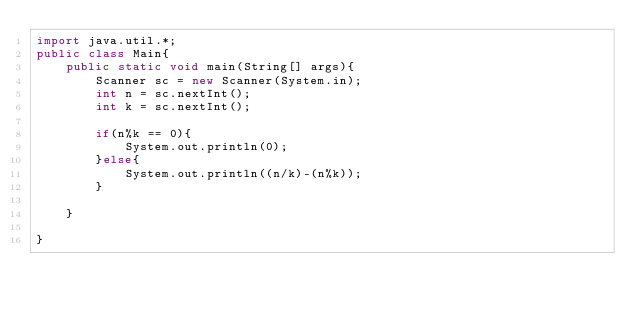Convert code to text. <code><loc_0><loc_0><loc_500><loc_500><_Java_>import java.util.*;
public class Main{
    public static void main(String[] args){
        Scanner sc = new Scanner(System.in);
        int n = sc.nextInt();
        int k = sc.nextInt();

        if(n%k == 0){
            System.out.println(0);
        }else{
            System.out.println((n/k)-(n%k));
        }

    }

}
</code> 